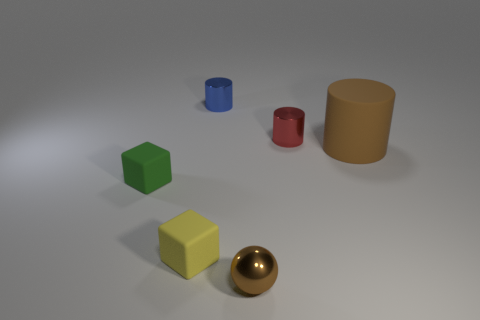Add 3 tiny objects. How many objects exist? 9 Subtract all tiny metal cylinders. How many cylinders are left? 1 Subtract all blue cylinders. How many cylinders are left? 2 Subtract 1 cylinders. How many cylinders are left? 2 Subtract all balls. How many objects are left? 5 Subtract all gray spheres. Subtract all cyan cylinders. How many spheres are left? 1 Subtract all cyan cylinders. How many green blocks are left? 1 Subtract all tiny matte cubes. Subtract all tiny matte objects. How many objects are left? 2 Add 5 red cylinders. How many red cylinders are left? 6 Add 5 tiny objects. How many tiny objects exist? 10 